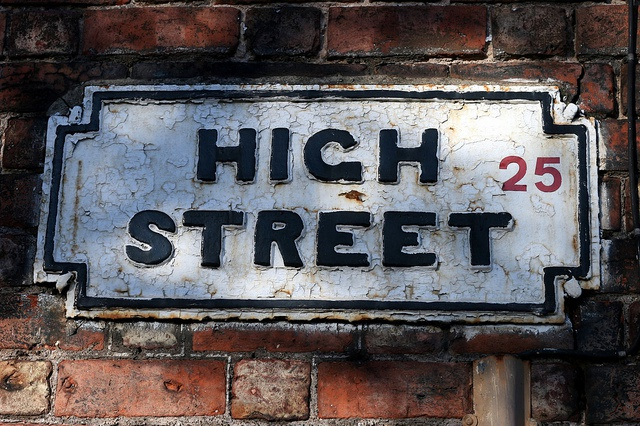Describe the objects in this image and their specific colors. I can see various objects in this image with different colors. 